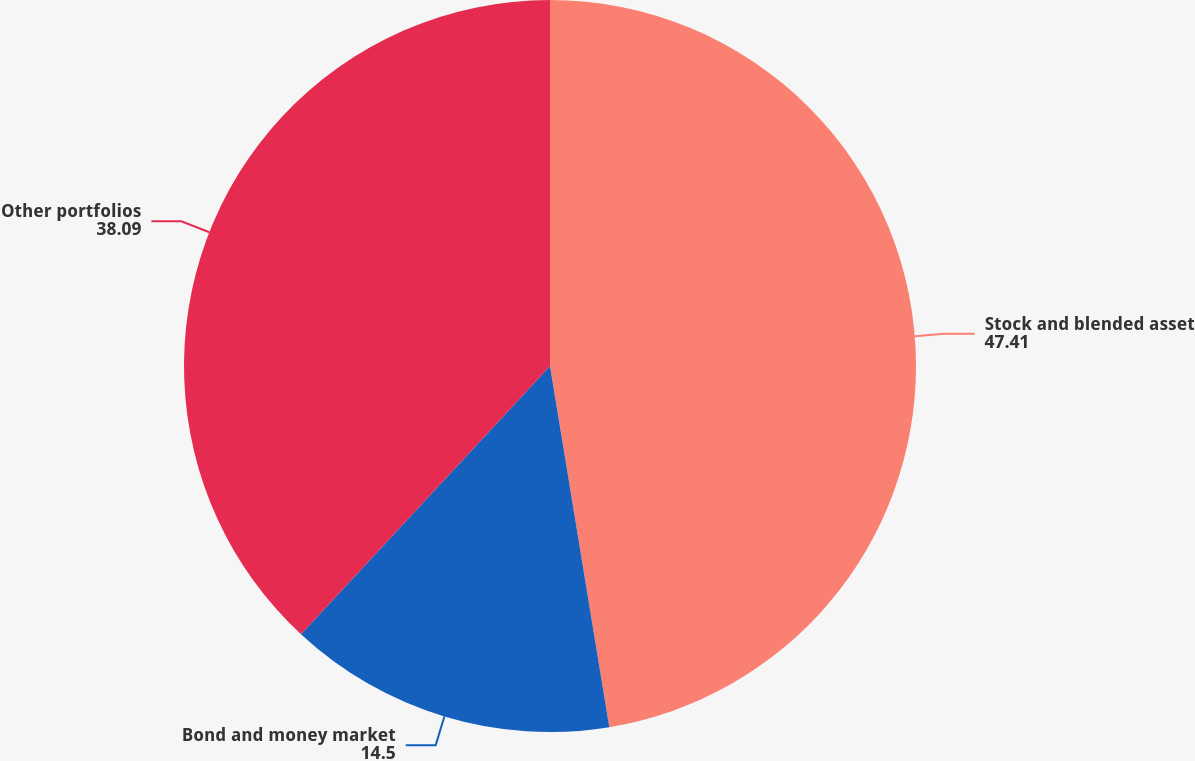<chart> <loc_0><loc_0><loc_500><loc_500><pie_chart><fcel>Stock and blended asset<fcel>Bond and money market<fcel>Other portfolios<nl><fcel>47.41%<fcel>14.5%<fcel>38.09%<nl></chart> 